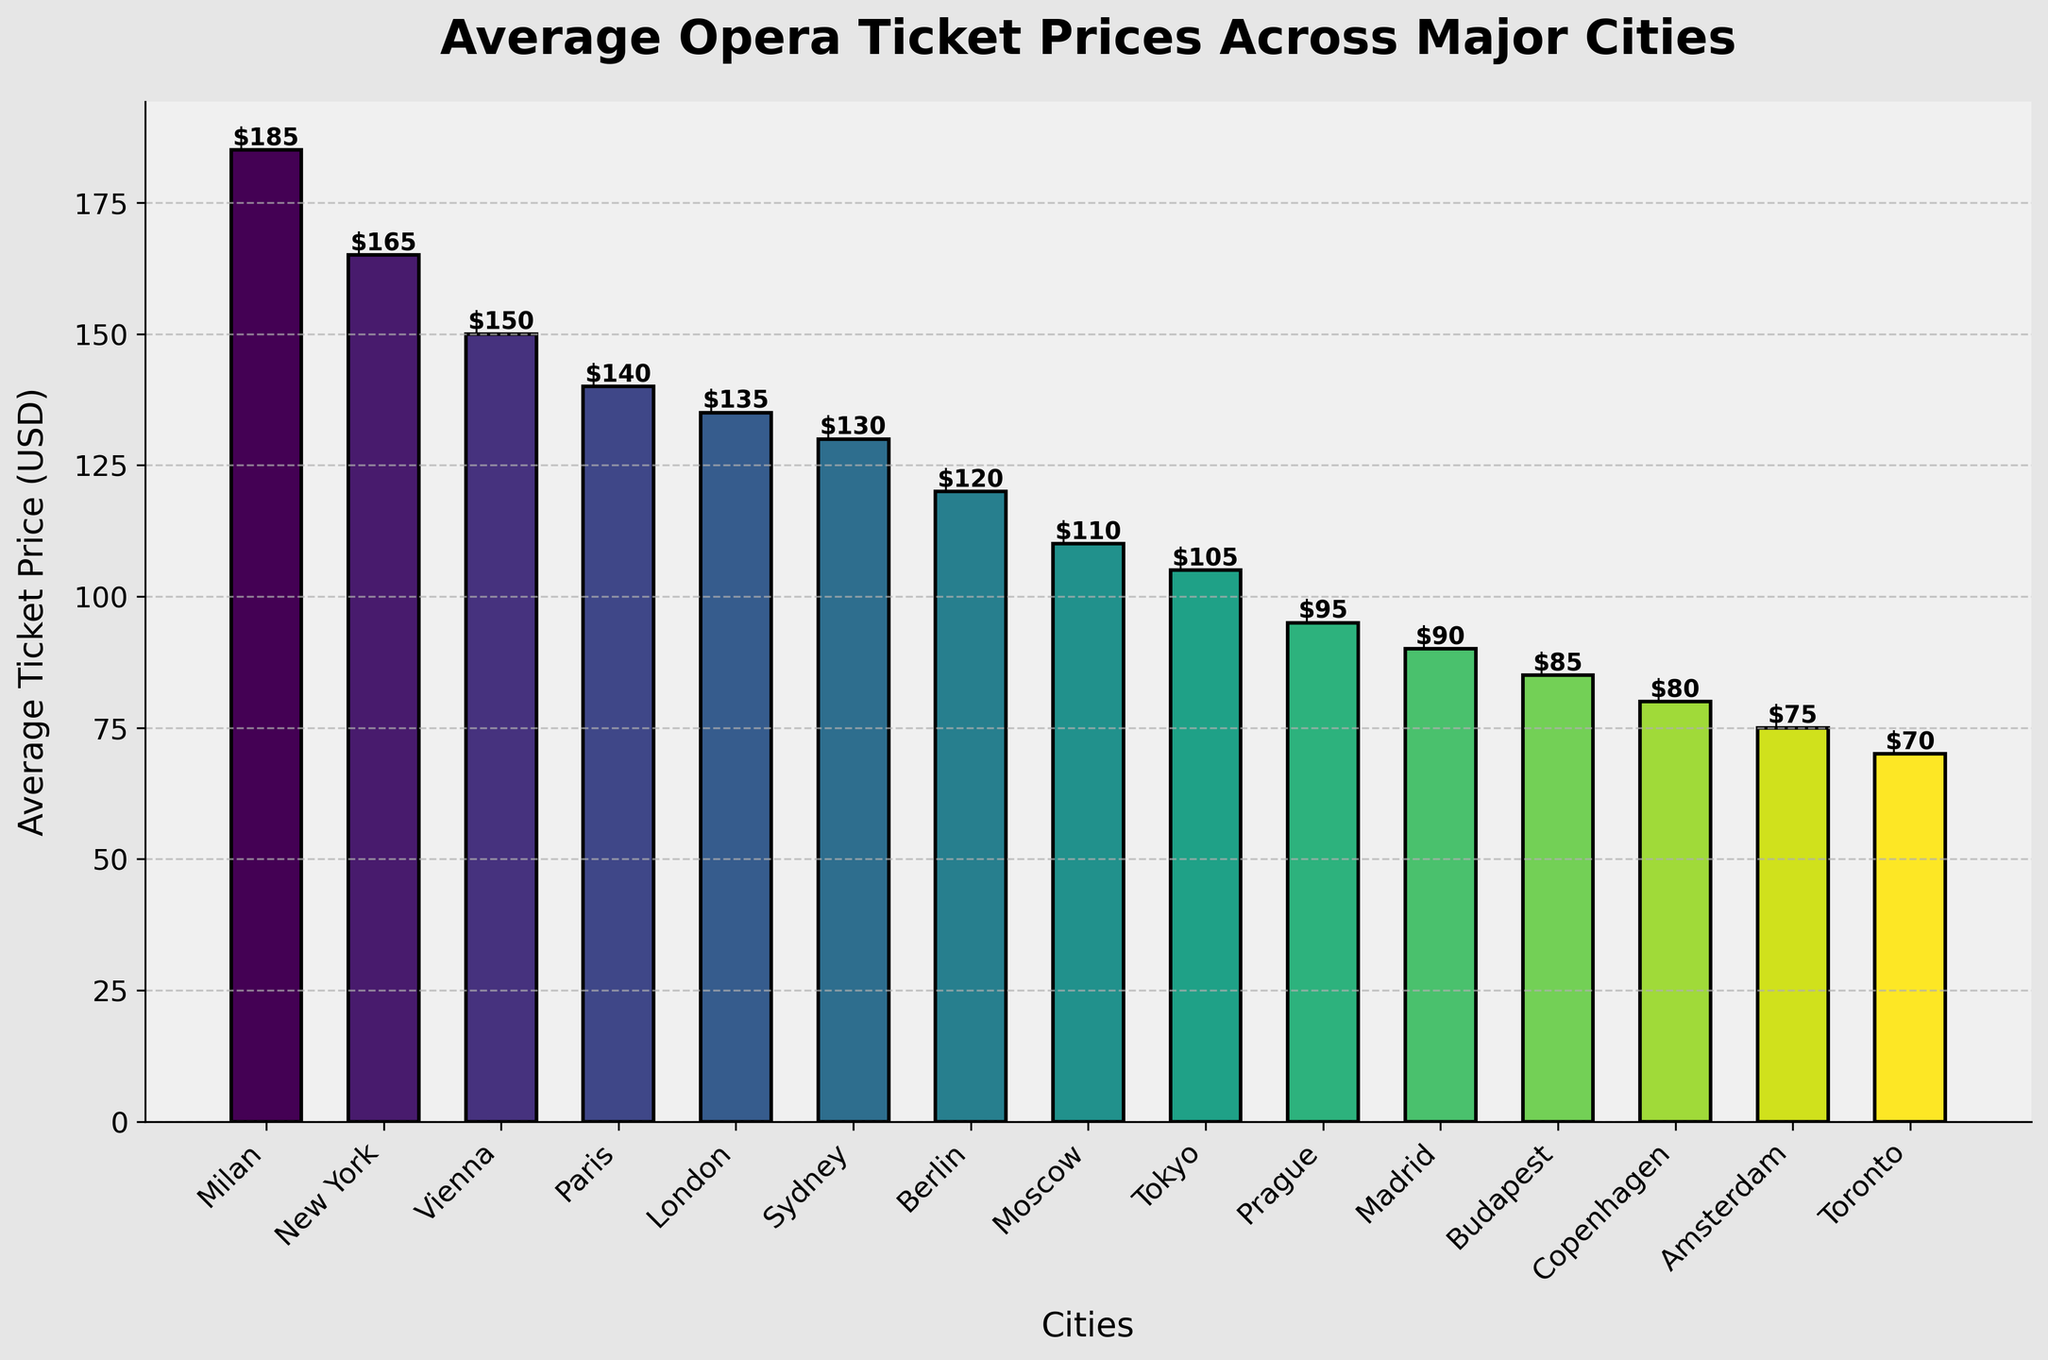Which city has the highest average ticket price for opera performances? Look at the bar chart and identify the tallest bar. The tallest bar represents Milan with an average ticket price of $185.
Answer: Milan Which two cities have the lowest average ticket prices for opera performances? Examine the bar chart and find the two shortest bars. The shortest bars represent Toronto with $70 and Amsterdam with $75.
Answer: Toronto and Amsterdam How much more expensive is the average ticket price in Milan compared to Prague? Determine the average ticket prices for Milan and Prague on the chart, then calculate the difference ($185 - $95).
Answer: $90 Which city has an average ticket price that is closest to the midpoint of the highest and lowest prices? Calculate the midpoint between the highest ($185 for Milan) and lowest ($70 for Toronto) prices, which is ($185 + $70) / 2 = $127.5. The city closest to this price is Sydney with $130.
Answer: Sydney Which cities have an average ticket price below $100? Identify bars that are shorter than the $100 mark on the y-axis. These cities are Prague ($95), Madrid ($90), Budapest ($85), Copenhagen ($80), Amsterdam ($75), and Toronto ($70).
Answer: Prague, Madrid, Budapest, Copenhagen, Amsterdam, Toronto Is the average ticket price in Vienna higher or lower than in New York? Compare the heights of the bars for Vienna ($150) and New York ($165). Vienna is lower.
Answer: Lower What is the total combined average ticket price for London, Berlin, and Moscow? Sum the average ticket prices for London ($135), Berlin ($120), and Moscow ($110). This results in $135 + $120 + $110 = $365.
Answer: $365 Which city has an average ticket price that most closely matches the average ticket price for Paris? Find the bar representing the average price for Paris ($140), then identify the bar closest in height, which is London with $135.
Answer: London How many cities have an average ticket price between $100 and $150 inclusive? Count the number of bars that fall within this range: Vienna ($150), Paris ($140), London ($135), Sydney ($130), Berlin ($120), and Moscow ($110). There are 6 cities in total.
Answer: 6 Which city has the second highest average ticket price, and what is that price? Identify the bar with the second greatest height, which is New York with $165.
Answer: New York, $165 